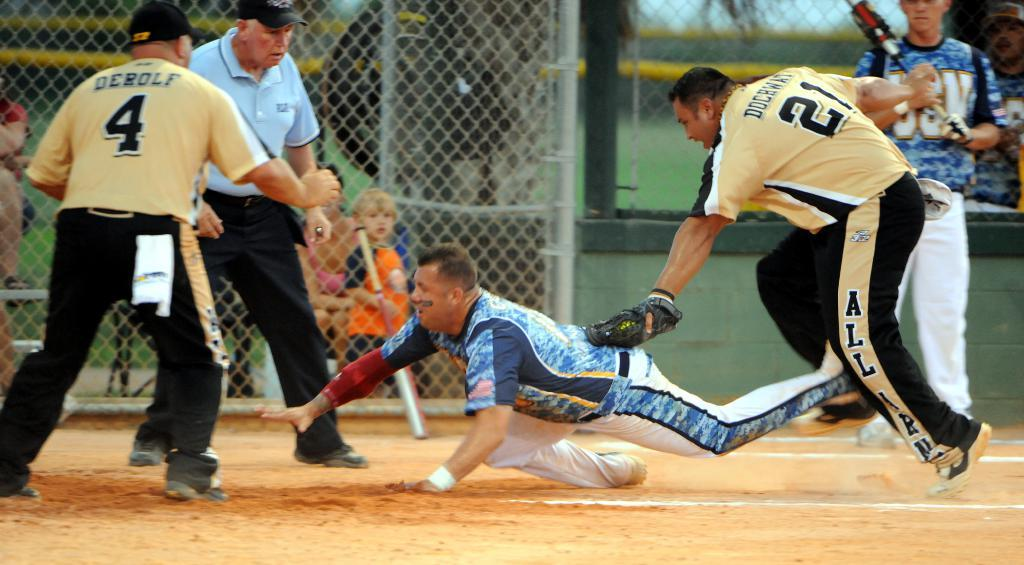<image>
Offer a succinct explanation of the picture presented. Number 21 is the on the uniform of the player tagging at home plate. 